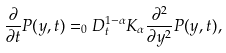<formula> <loc_0><loc_0><loc_500><loc_500>\frac { \partial } { \partial t } P ( y , t ) = _ { 0 } D _ { t } ^ { 1 - \alpha } K _ { \alpha } \frac { \partial ^ { 2 } } { \partial y ^ { 2 } } P ( y , t ) ,</formula> 